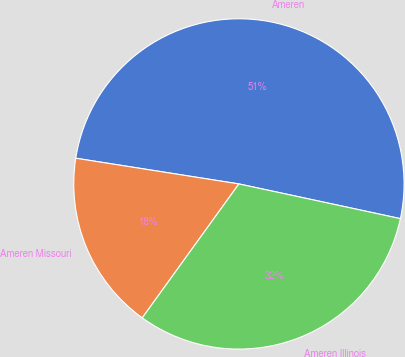<chart> <loc_0><loc_0><loc_500><loc_500><pie_chart><fcel>Ameren<fcel>Ameren Missouri<fcel>Ameren Illinois<nl><fcel>50.88%<fcel>17.54%<fcel>31.58%<nl></chart> 